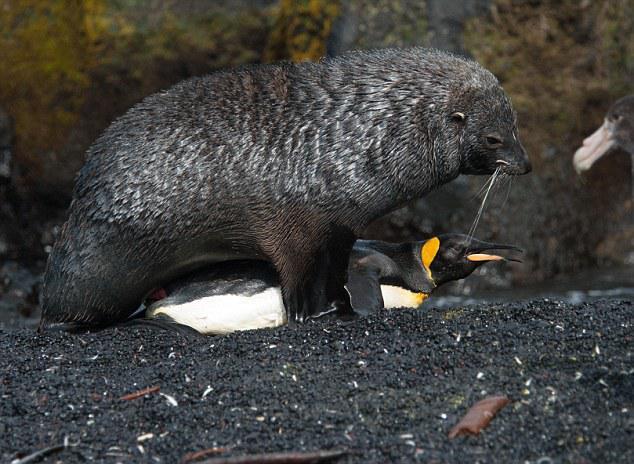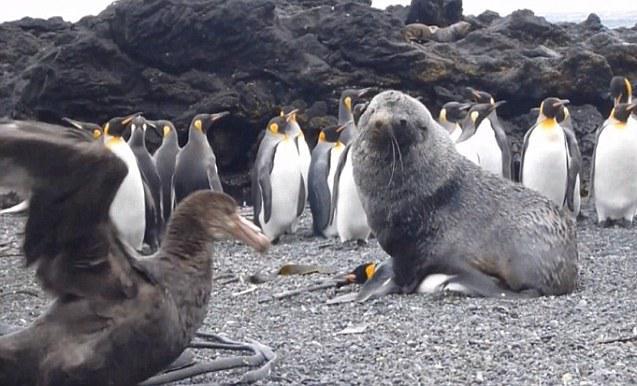The first image is the image on the left, the second image is the image on the right. Evaluate the accuracy of this statement regarding the images: "There is a single black platypusfacing left  on top of a white, black, and yellow penguin". Is it true? Answer yes or no. Yes. 